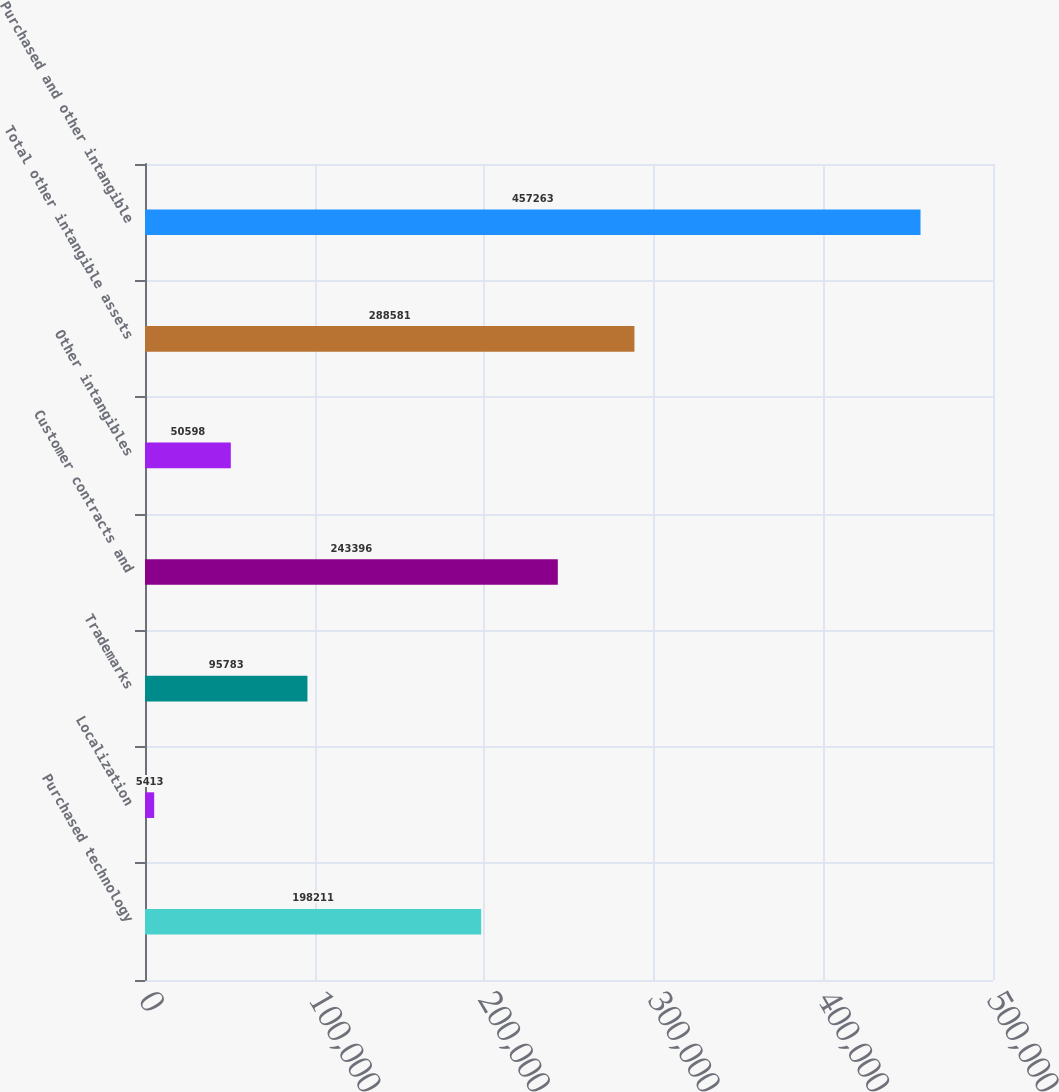Convert chart to OTSL. <chart><loc_0><loc_0><loc_500><loc_500><bar_chart><fcel>Purchased technology<fcel>Localization<fcel>Trademarks<fcel>Customer contracts and<fcel>Other intangibles<fcel>Total other intangible assets<fcel>Purchased and other intangible<nl><fcel>198211<fcel>5413<fcel>95783<fcel>243396<fcel>50598<fcel>288581<fcel>457263<nl></chart> 